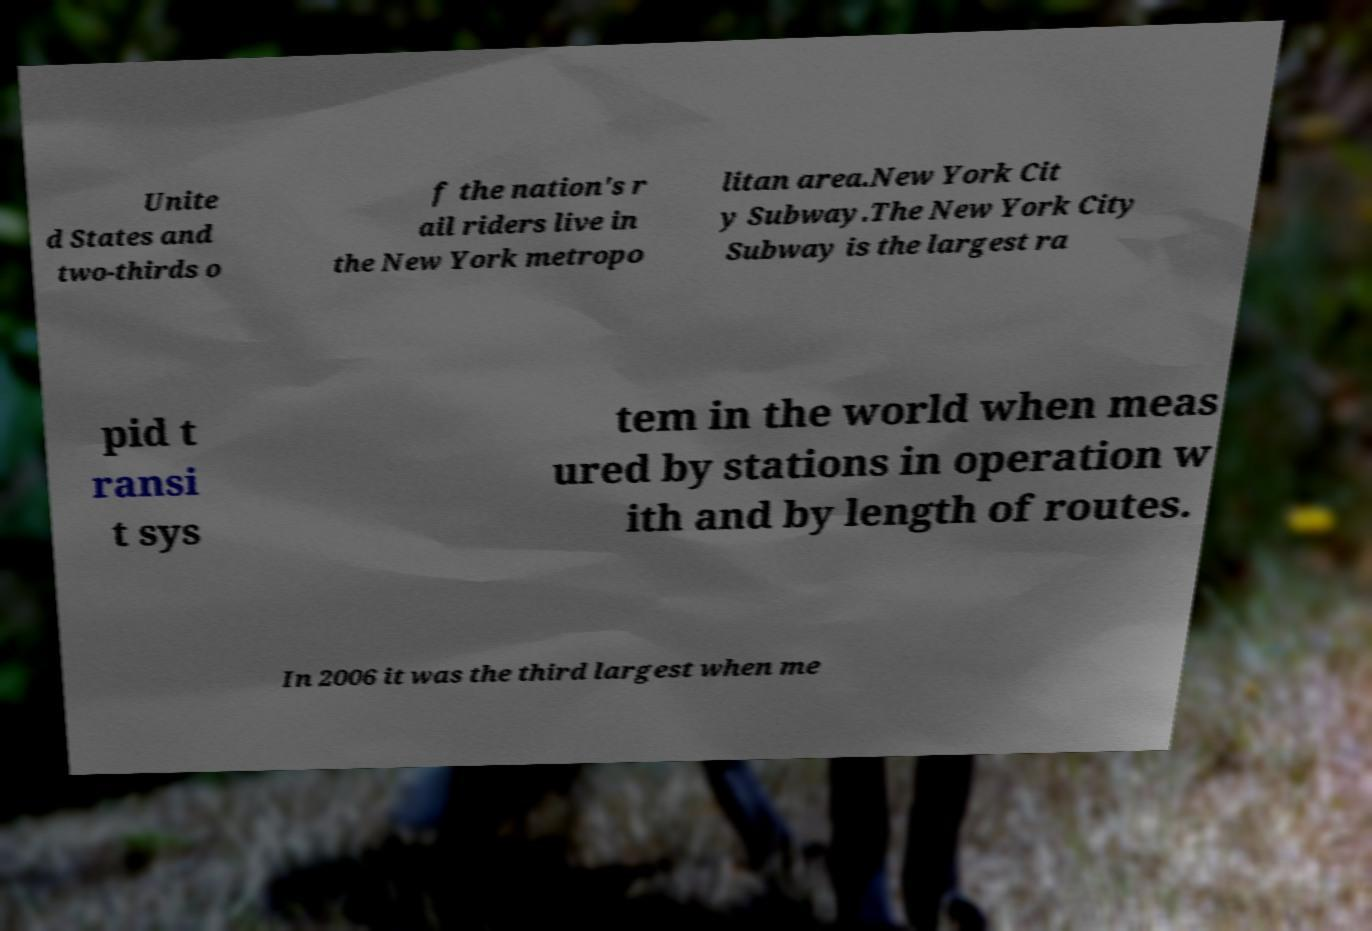For documentation purposes, I need the text within this image transcribed. Could you provide that? Unite d States and two-thirds o f the nation's r ail riders live in the New York metropo litan area.New York Cit y Subway.The New York City Subway is the largest ra pid t ransi t sys tem in the world when meas ured by stations in operation w ith and by length of routes. In 2006 it was the third largest when me 